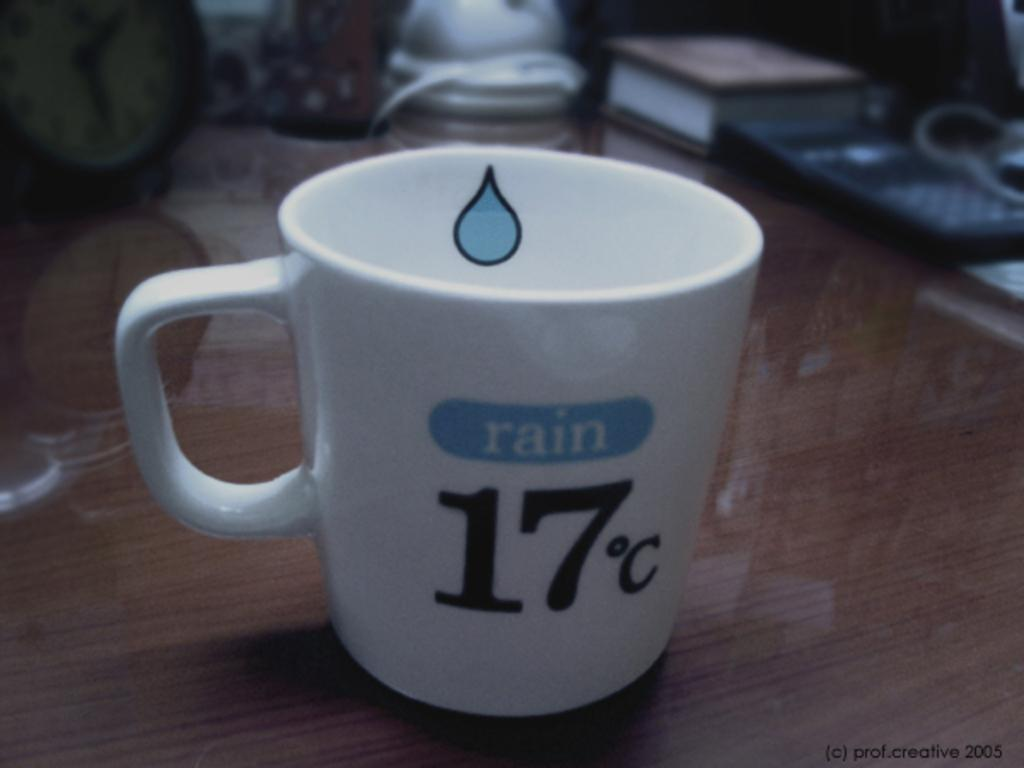<image>
Describe the image concisely. a cup with the number 17 written on it 